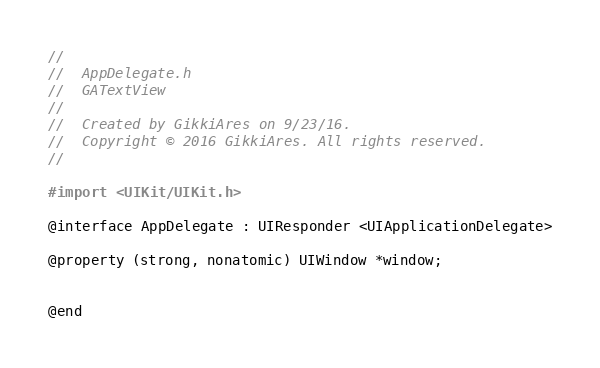Convert code to text. <code><loc_0><loc_0><loc_500><loc_500><_C_>//
//  AppDelegate.h
//  GATextView
//
//  Created by GikkiAres on 9/23/16.
//  Copyright © 2016 GikkiAres. All rights reserved.
//

#import <UIKit/UIKit.h>

@interface AppDelegate : UIResponder <UIApplicationDelegate>

@property (strong, nonatomic) UIWindow *window;


@end

</code> 